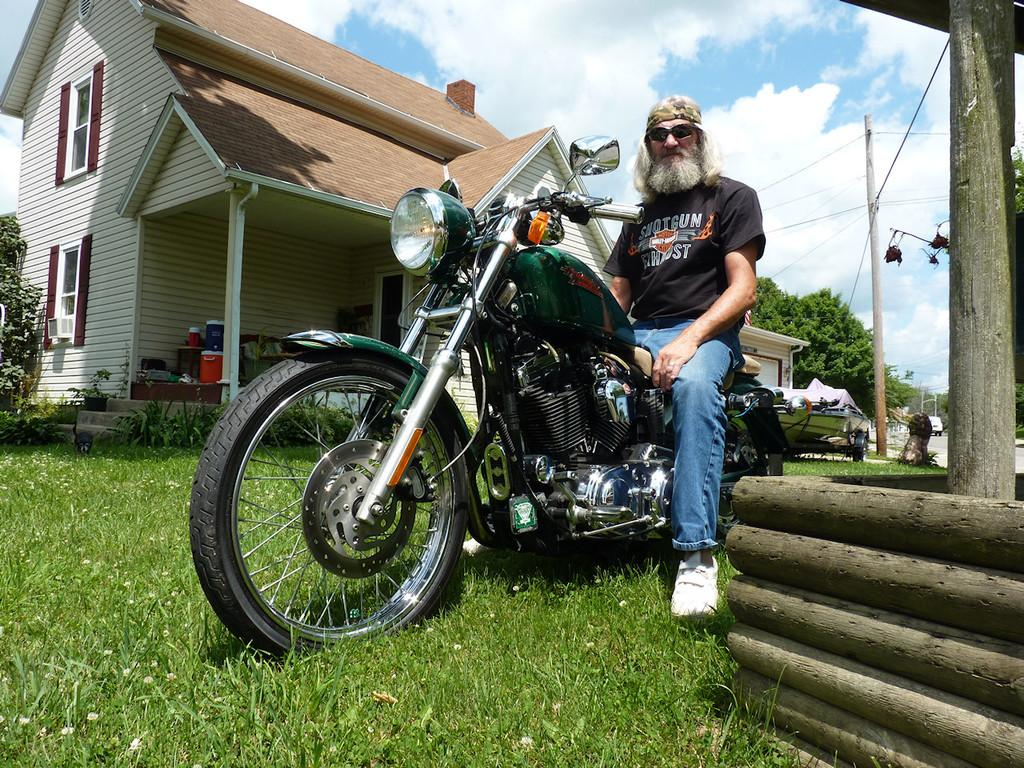What is the man doing in the image? The man is on a bike in the image. What type of terrain is visible in the image? There is grass in the image. What type of structure can be seen in the image? There is a house in the image. What is visible in the background of the image? The sky is visible in the background of the image. What is the weather like in the image? The sky has heavy clouds, suggesting it might be overcast or rainy. What other objects are present in the image? There is a pole and trees in the image. What type of soup is being served in the image? There is no soup present in the image; it features a man on a bike, grass, a house, the sky, heavy clouds, a pole, and trees. 